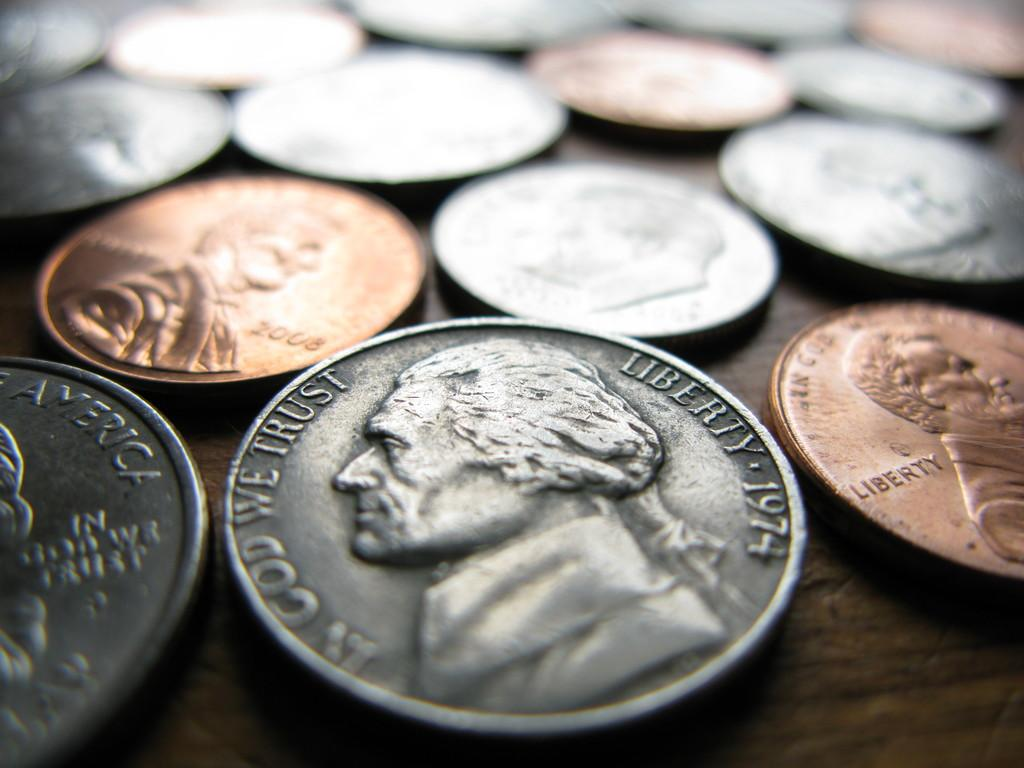<image>
Provide a brief description of the given image. In God We Trust, Liberty 1974 is stamped around the edges of this coin. 